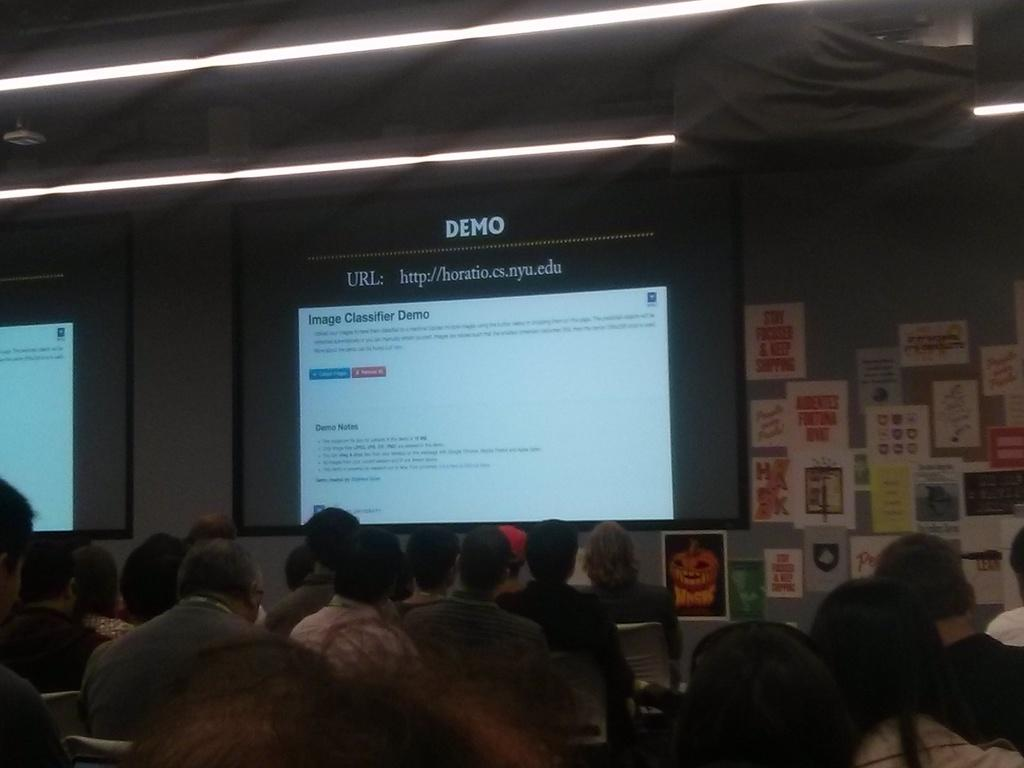What are the people in the image doing? The people in the image are sitting on chairs. What device is present in the image for displaying visuals? There is a projector in the image. What surface is used for displaying the projected visuals? There is a projector screen in the image. What can be seen on the right side of the image? There are posts on the wall on the right side of the image. What color of paint is being used on the road in the image? There is no road present in the image, so it is not possible to determine the color of paint being used. 